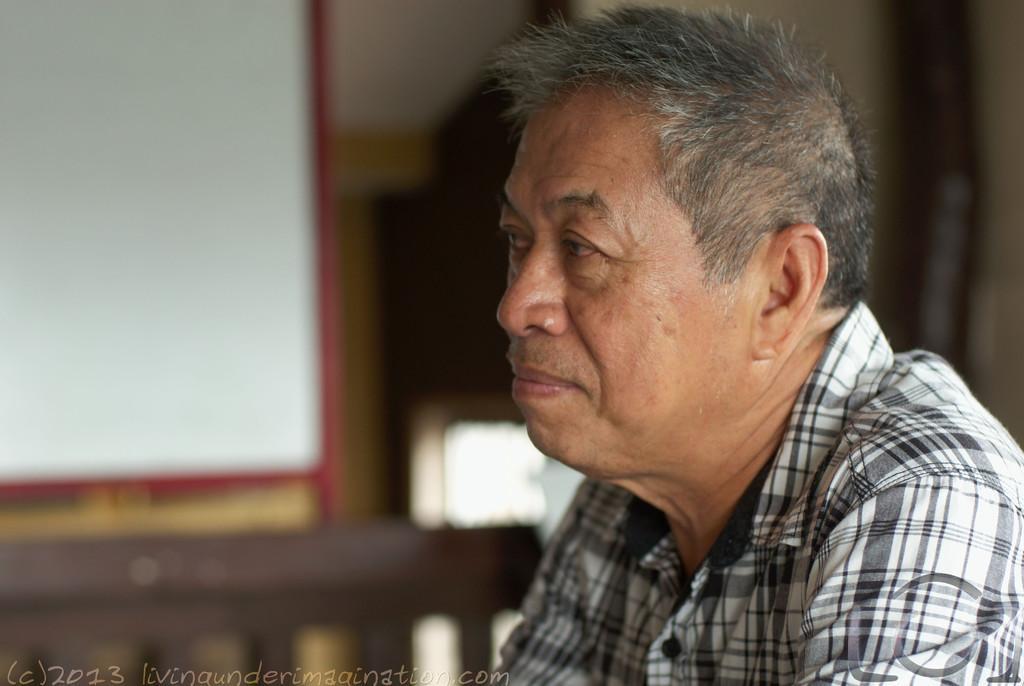Please provide a concise description of this image. There is a man wore shirt. In the background it is blur. In the bottom left side of the image we can see watermark. 